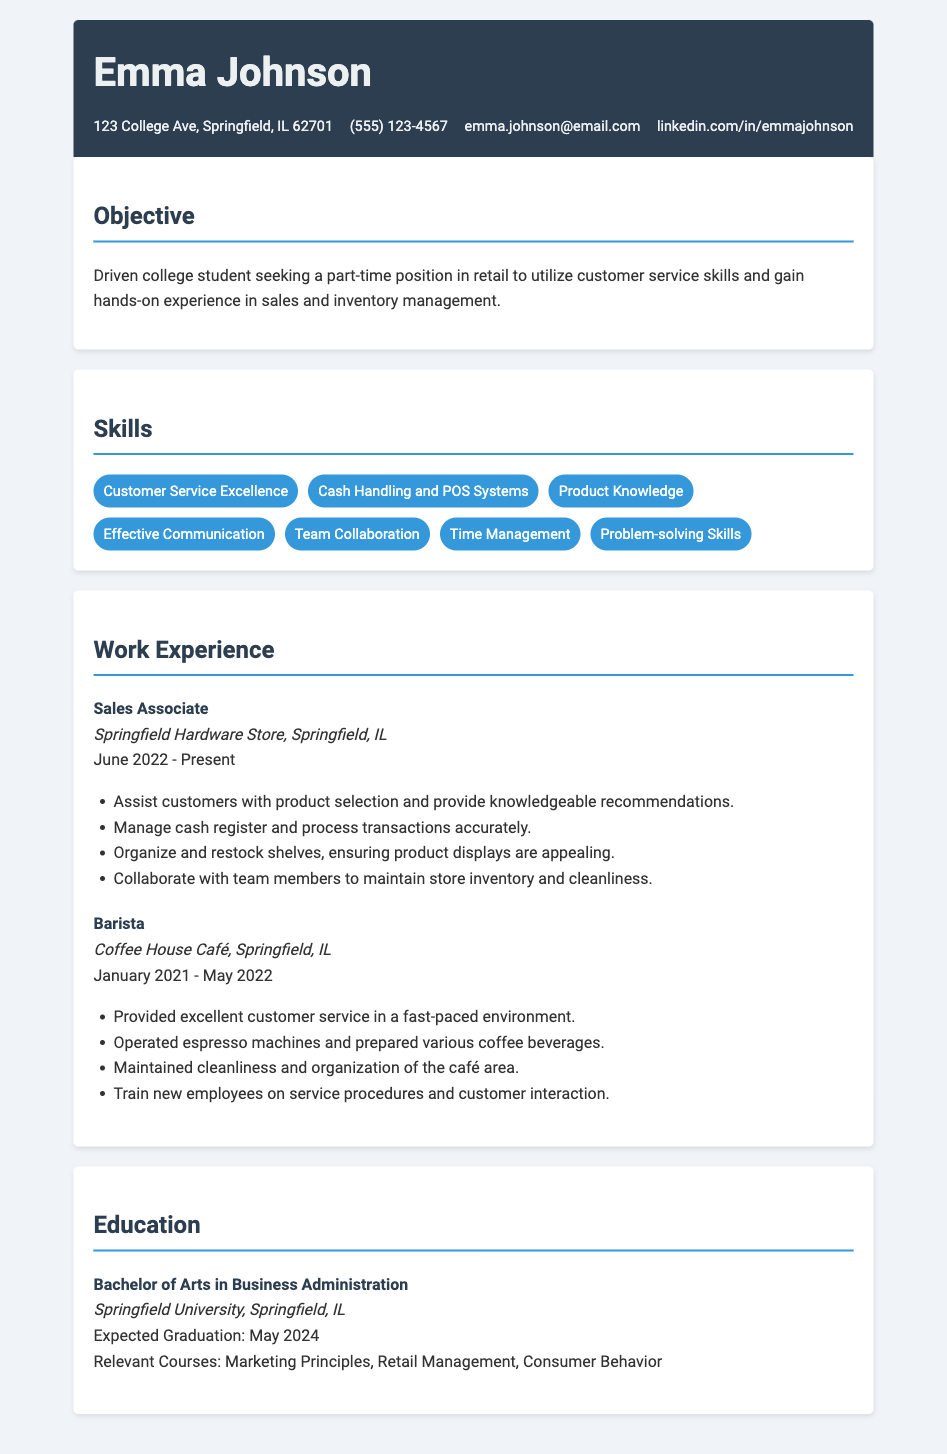what is the name of the person on the resume? The name is displayed prominently at the top of the resume.
Answer: Emma Johnson what is the phone number listed in the contact information? The phone number can be found in the contact section of the document.
Answer: (555) 123-4567 which position is currently held by Emma? This information is listed under work experience in the document.
Answer: Sales Associate what is the expected graduation date? The expected graduation date is mentioned in the education section.
Answer: May 2024 how many skills are listed in the skills section? The skills section contains several skill items that can be counted.
Answer: 7 what is the name of the company where Emma worked as a Barista? The company name is listed under the work experience section.
Answer: Coffee House Café what degree is Emma pursuing? The degree is specified in the education section of the document.
Answer: Bachelor of Arts in Business Administration which skill emphasizes effective teamwork? This information can be determined from the skills listed.
Answer: Team Collaboration what is one of the duties of a Sales Associate? Duties are listed under each job experience in the document.
Answer: Assist customers with product selection and provide knowledgeable recommendations 